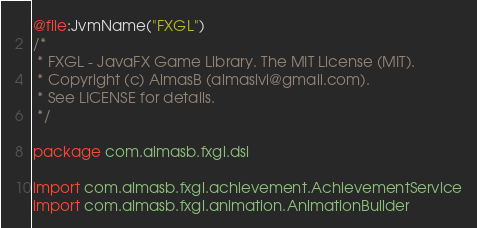Convert code to text. <code><loc_0><loc_0><loc_500><loc_500><_Kotlin_>@file:JvmName("FXGL")
/*
 * FXGL - JavaFX Game Library. The MIT License (MIT).
 * Copyright (c) AlmasB (almaslvl@gmail.com).
 * See LICENSE for details.
 */

package com.almasb.fxgl.dsl

import com.almasb.fxgl.achievement.AchievementService
import com.almasb.fxgl.animation.AnimationBuilder</code> 